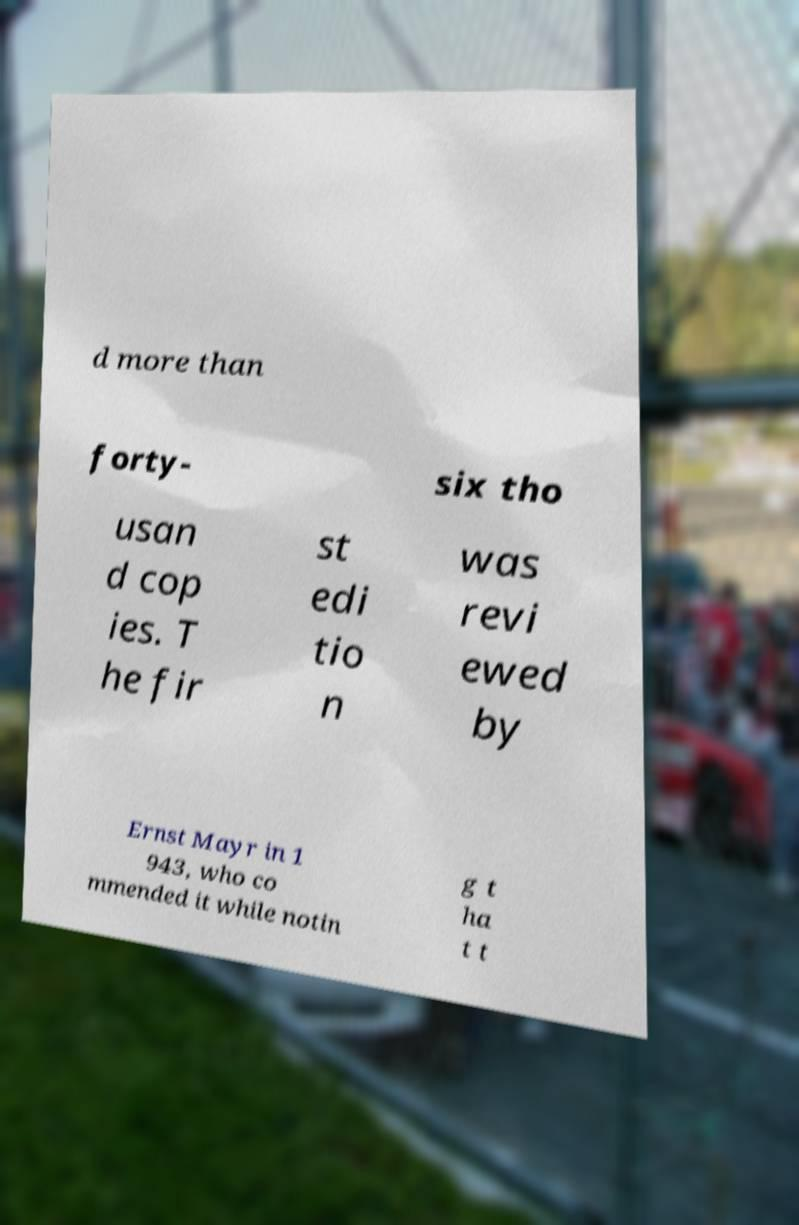There's text embedded in this image that I need extracted. Can you transcribe it verbatim? d more than forty- six tho usan d cop ies. T he fir st edi tio n was revi ewed by Ernst Mayr in 1 943, who co mmended it while notin g t ha t t 